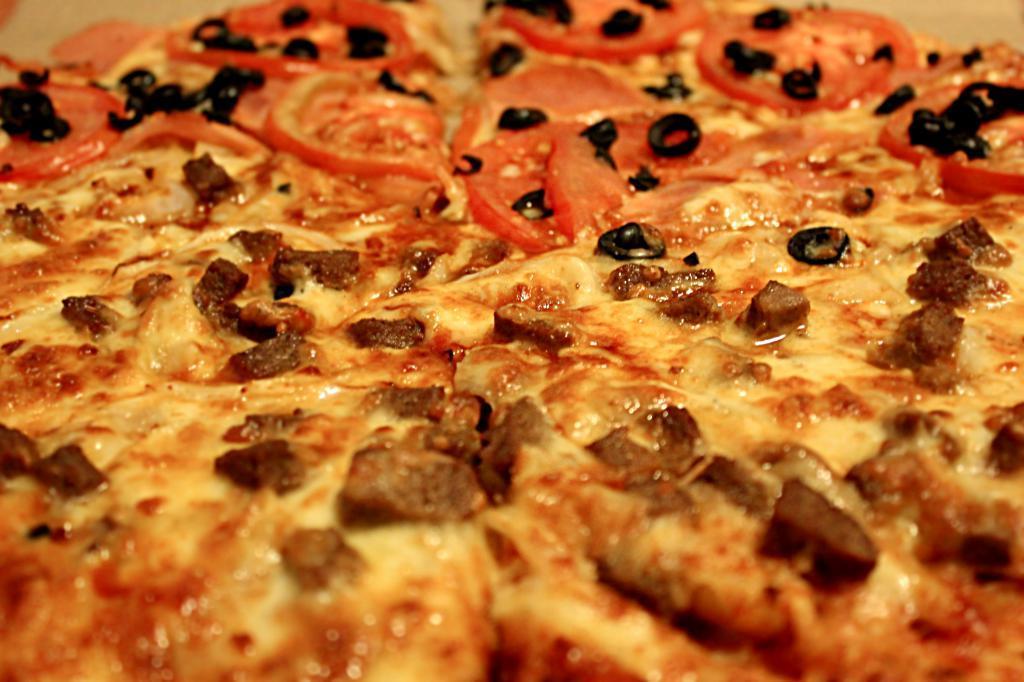Please provide a concise description of this image. In this picture I can see pizza. 